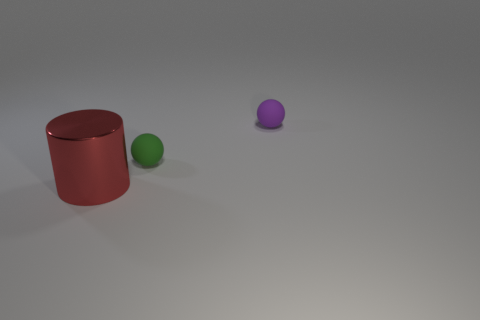Subtract 2 spheres. How many spheres are left? 0 Subtract all cylinders. How many objects are left? 2 Add 2 large red metal cylinders. How many objects exist? 5 Subtract 0 yellow balls. How many objects are left? 3 Subtract all green balls. Subtract all purple cylinders. How many balls are left? 1 Subtract all green cubes. How many green spheres are left? 1 Subtract all tiny brown matte objects. Subtract all purple matte spheres. How many objects are left? 2 Add 2 small purple objects. How many small purple objects are left? 3 Add 2 large blue cubes. How many large blue cubes exist? 2 